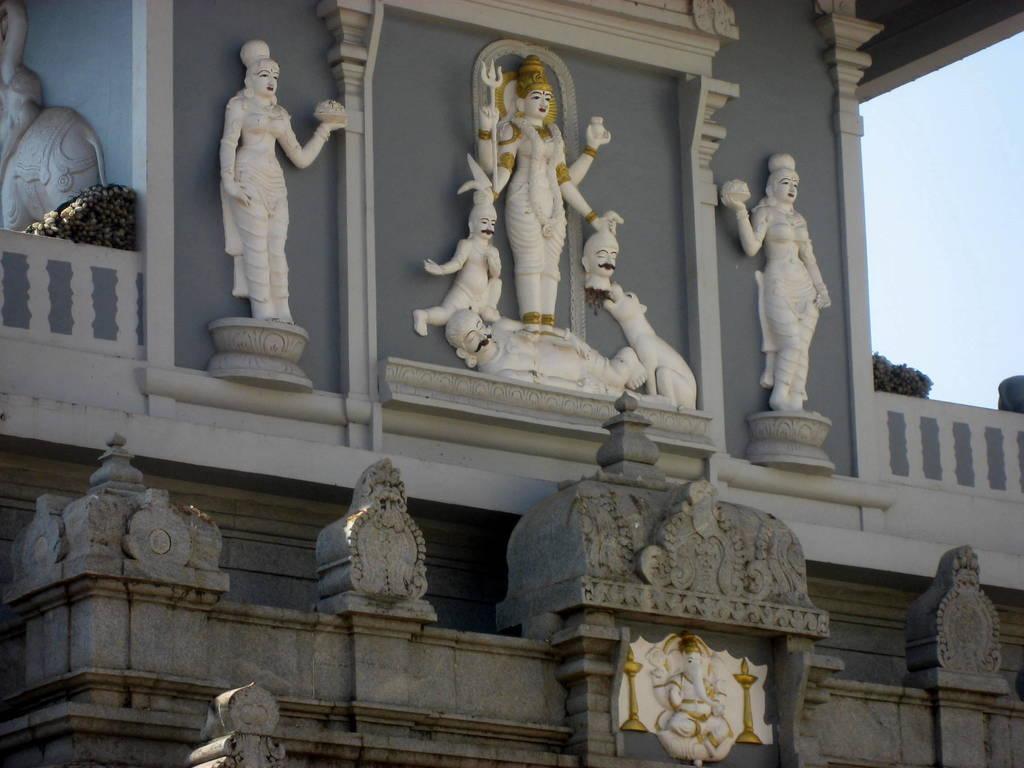In one or two sentences, can you explain what this image depicts? Here I can see a building and few statues to the wall. On the right side, I can see the sky. 